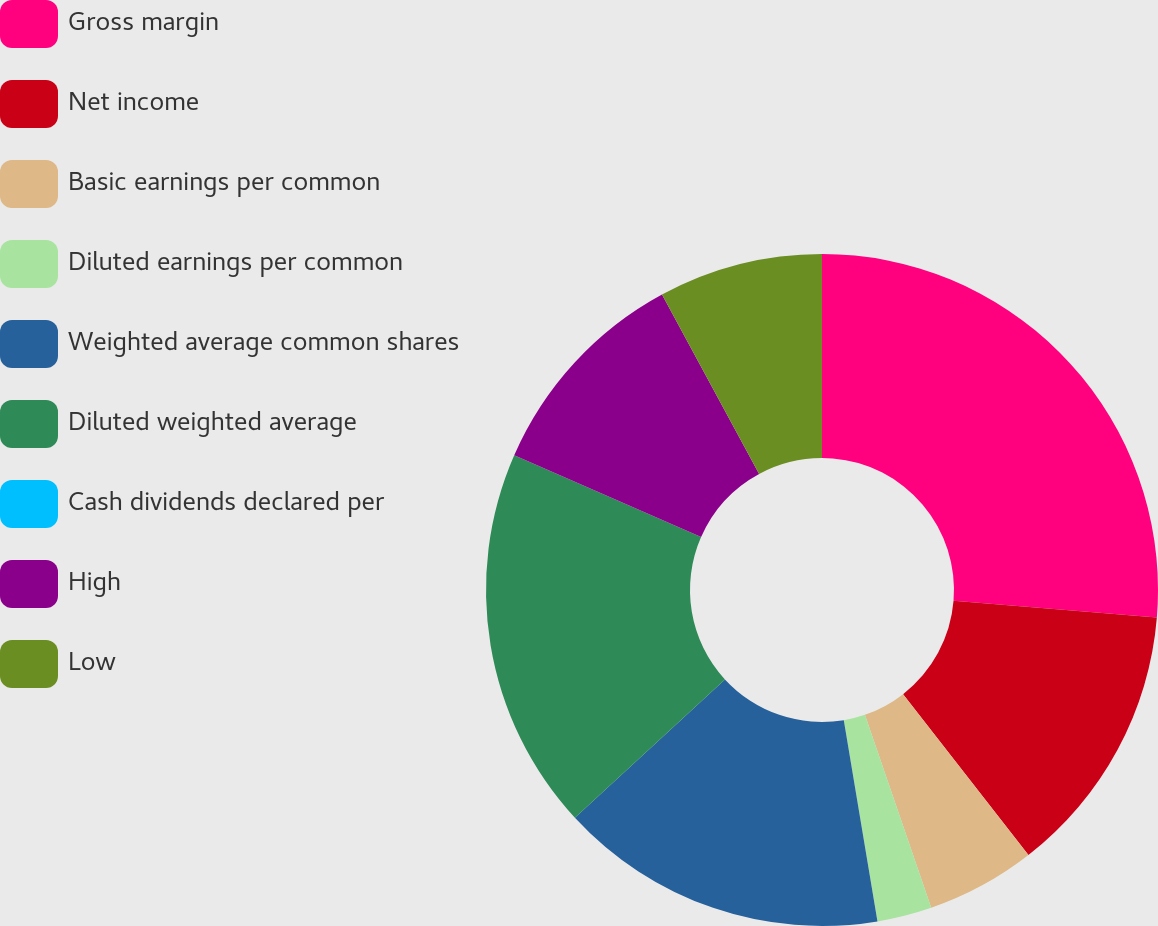<chart> <loc_0><loc_0><loc_500><loc_500><pie_chart><fcel>Gross margin<fcel>Net income<fcel>Basic earnings per common<fcel>Diluted earnings per common<fcel>Weighted average common shares<fcel>Diluted weighted average<fcel>Cash dividends declared per<fcel>High<fcel>Low<nl><fcel>26.31%<fcel>13.16%<fcel>5.26%<fcel>2.63%<fcel>15.79%<fcel>18.42%<fcel>0.0%<fcel>10.53%<fcel>7.9%<nl></chart> 